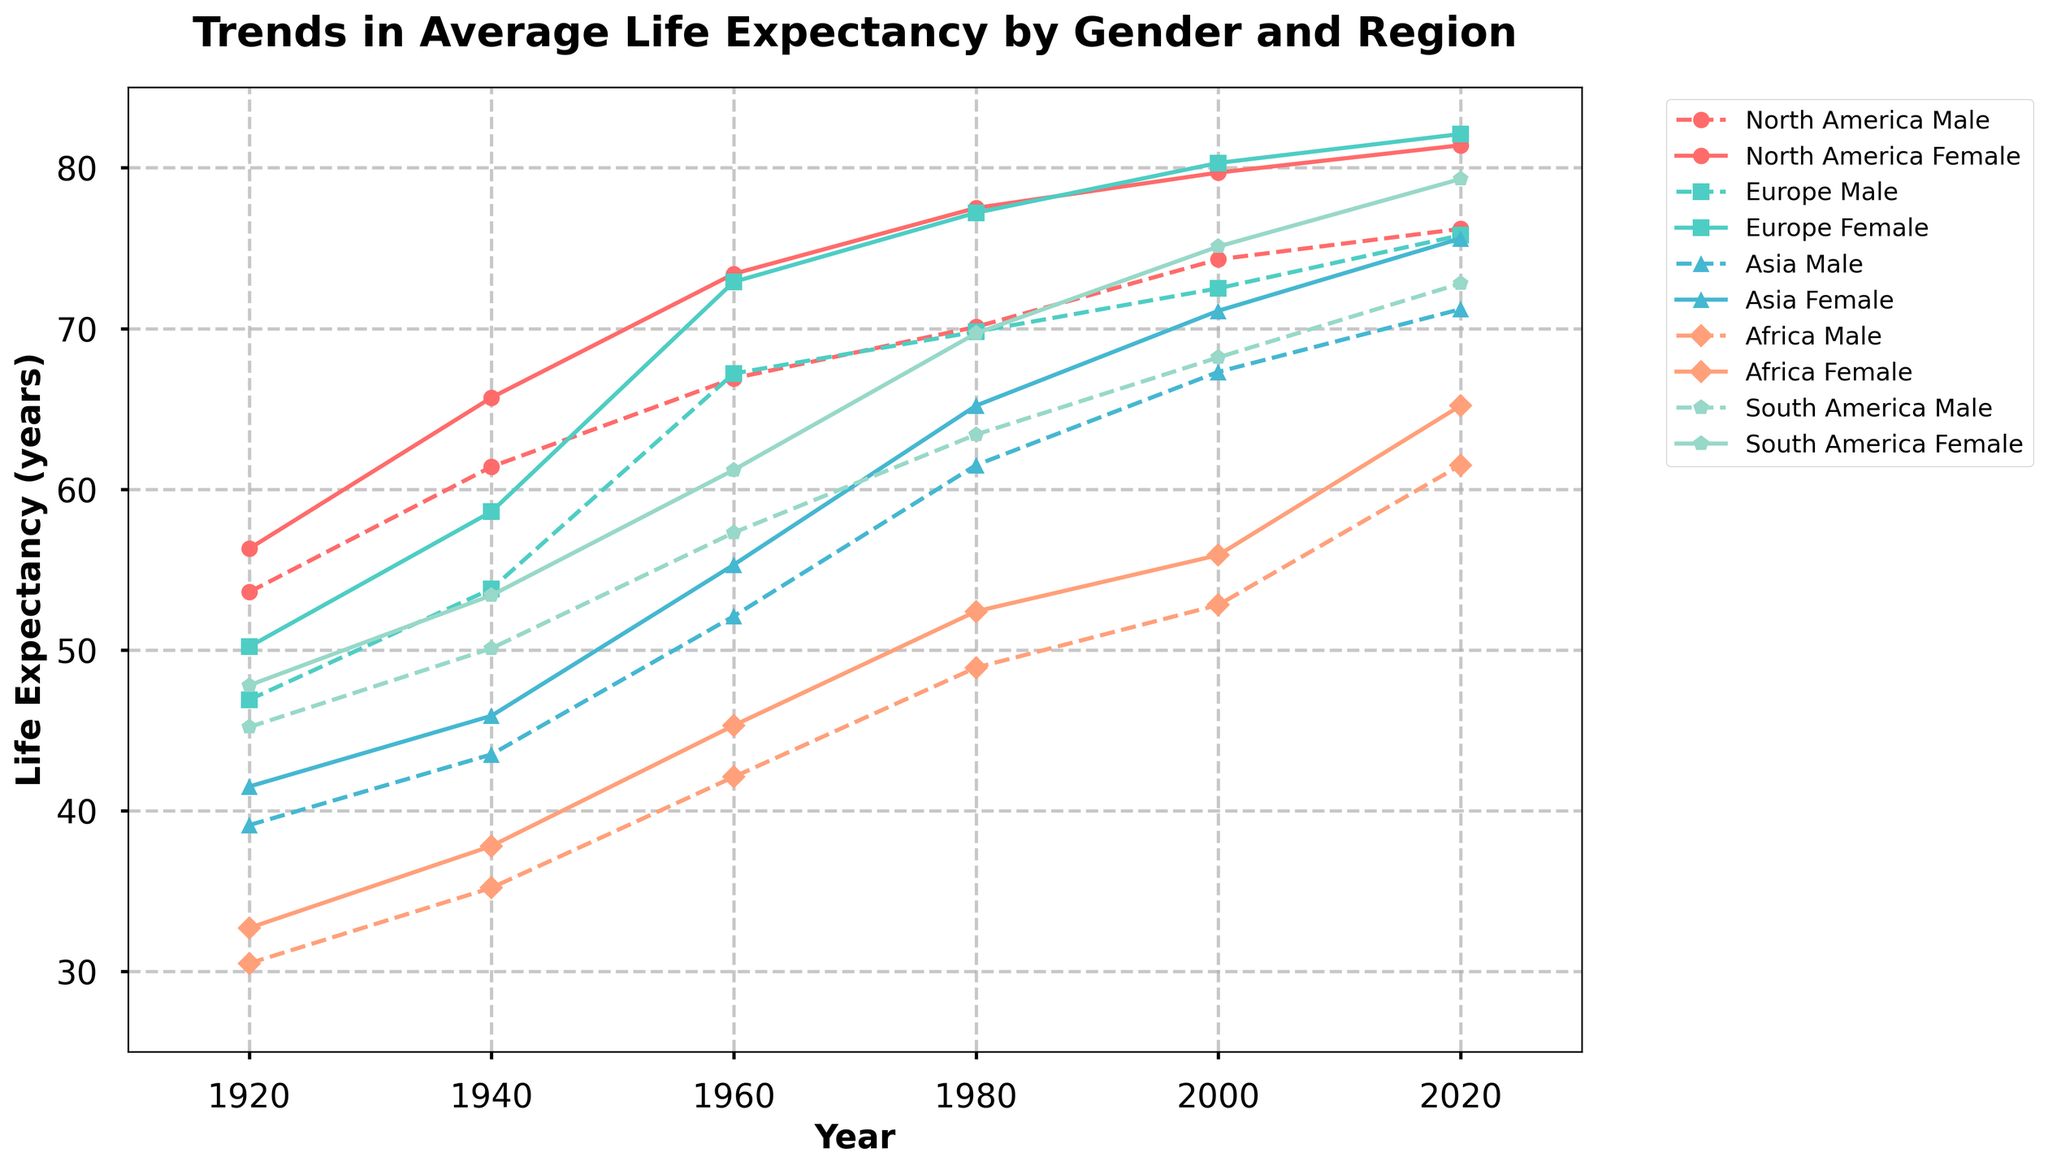What is the trend in life expectancy for North American females from 1920 to 2020? From the figure, identify the line corresponding to North American females and observe its general movement from 1920 to 2020. The line steadily rises, indicating an increase in life expectancy over the century.
Answer: Increasing trend Compare the life expectancy of African males and females in 2020. Which gender has a higher life expectancy? Look at the endpoints of the lines corresponding to African males and females in 2020. The line for African females ends higher than the line for African males, indicating that females have a higher life expectancy in 2020.
Answer: African females By how many years did the life expectancy of European males increase from 1940 to 2020? Find the points for European males in 1940 and 2020. Subtract the 1940 value from the 2020 value: 75.8 (2020) - 53.8 (1940) = 22 years.
Answer: 22 years Which region had the greatest increase in life expectancy for females from 1920 to 2020? Observe the female life expectancy lines for all regions and measure the vertical distance between their starting points in 1920 and endpoints in 2020. North America has the greatest vertical distance.
Answer: North America In 1980, which gender had a higher life expectancy in Asia, and by how many years? Compare the points for Asian males and females in 1980. Subtract the male value from the female value: 65.2 (female) - 61.5 (male) = 3.7 years.
Answer: Females, 3.7 years What can you infer about the difference in life expectancy between genders in each region across the century? Observe the gaps between the male and female lines for each region. Typically, the female lines are above the male lines, indicating that females generally have a higher life expectancy across all regions and time periods.
Answer: Females generally have higher life expectancy Calculate the average life expectancy for South American males across all recorded years. Sum the life expectancy values for South American males and divide by the number of years: (45.2 + 50.1 + 57.3 + 63.4 + 68.2 + 72.8)/6 = 59.5 years.
Answer: 59.5 years Between 1940 and 1980, which region saw the greatest increase in life expectancy for males? Examine the male life expectancy values for each region in 1940 and 1980. Calculate the differences and identify the greatest increase. Africa: 48.9 - 35.2 = 13.7, Asia: 61.5 - 43.5 = 18, Europe: 69.8 - 53.8 = 16, North America: 70.1 - 61.4 = 8.7, South America: 63.4 - 50.1 = 13.3.
Answer: Asia Which region had the most consistent increase in life expectancy for both genders from 1920 to 2020? Look for the region where both male and female lines increase steadily with the least amount of fluctuation or narrowing/widening of the gap between the genders. North America appears to have the most consistent increase.
Answer: North America 